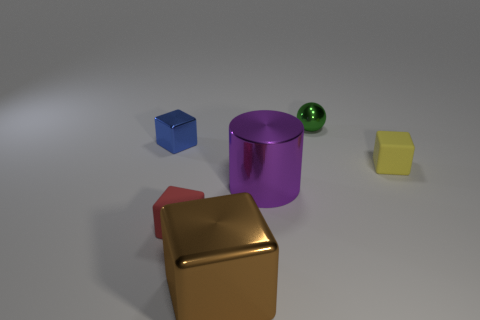Subtract all tiny blocks. How many blocks are left? 1 Add 2 brown metallic blocks. How many objects exist? 8 Add 3 purple cylinders. How many purple cylinders are left? 4 Add 2 tiny yellow rubber things. How many tiny yellow rubber things exist? 3 Subtract all yellow blocks. How many blocks are left? 3 Subtract 0 blue cylinders. How many objects are left? 6 Subtract all cubes. How many objects are left? 2 Subtract 2 cubes. How many cubes are left? 2 Subtract all blue balls. Subtract all yellow cubes. How many balls are left? 1 Subtract all blue blocks. How many blue balls are left? 0 